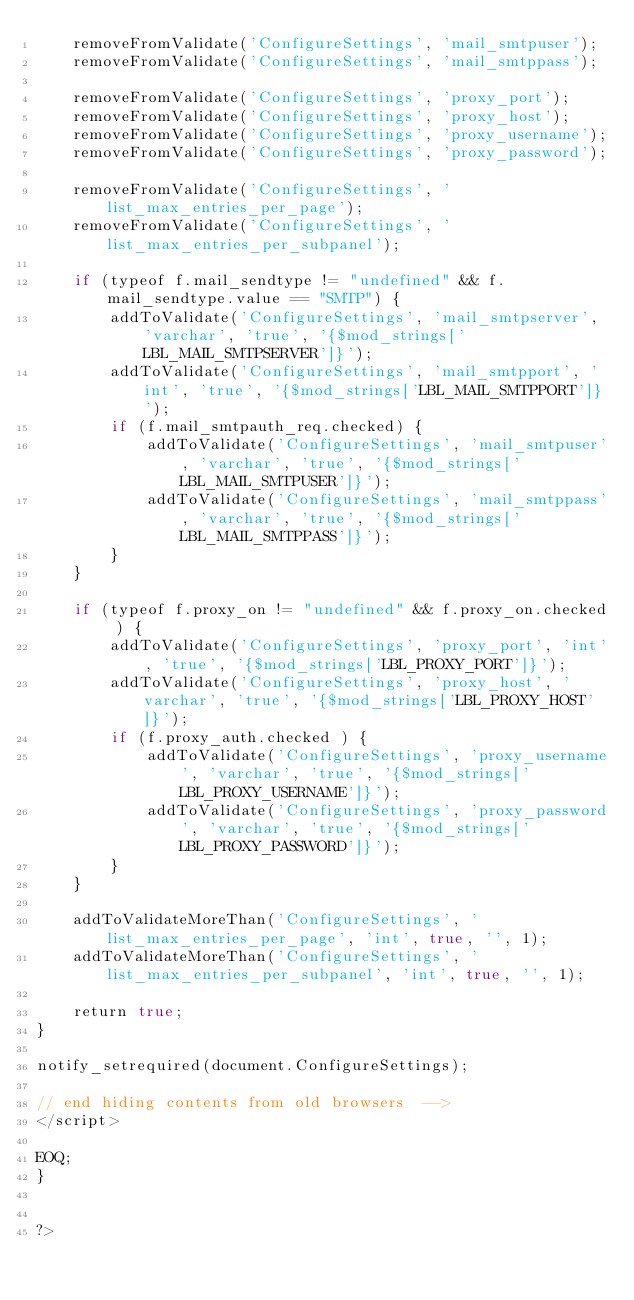<code> <loc_0><loc_0><loc_500><loc_500><_PHP_>	removeFromValidate('ConfigureSettings', 'mail_smtpuser');
	removeFromValidate('ConfigureSettings', 'mail_smtppass');
	
	removeFromValidate('ConfigureSettings', 'proxy_port');
	removeFromValidate('ConfigureSettings', 'proxy_host');
	removeFromValidate('ConfigureSettings', 'proxy_username');
	removeFromValidate('ConfigureSettings', 'proxy_password');
	
	removeFromValidate('ConfigureSettings', 'list_max_entries_per_page');
	removeFromValidate('ConfigureSettings', 'list_max_entries_per_subpanel');	
	
	if (typeof f.mail_sendtype != "undefined" && f.mail_sendtype.value == "SMTP") {
		addToValidate('ConfigureSettings', 'mail_smtpserver', 'varchar', 'true', '{$mod_strings['LBL_MAIL_SMTPSERVER']}');
		addToValidate('ConfigureSettings', 'mail_smtpport', 'int', 'true', '{$mod_strings['LBL_MAIL_SMTPPORT']}');
		if (f.mail_smtpauth_req.checked) {
			addToValidate('ConfigureSettings', 'mail_smtpuser', 'varchar', 'true', '{$mod_strings['LBL_MAIL_SMTPUSER']}');
			addToValidate('ConfigureSettings', 'mail_smtppass', 'varchar', 'true', '{$mod_strings['LBL_MAIL_SMTPPASS']}');
		}
	}
	
	if (typeof f.proxy_on != "undefined" && f.proxy_on.checked ) {
		addToValidate('ConfigureSettings', 'proxy_port', 'int', 'true', '{$mod_strings['LBL_PROXY_PORT']}');
		addToValidate('ConfigureSettings', 'proxy_host', 'varchar', 'true', '{$mod_strings['LBL_PROXY_HOST']}');
		if (f.proxy_auth.checked ) {
			addToValidate('ConfigureSettings', 'proxy_username', 'varchar', 'true', '{$mod_strings['LBL_PROXY_USERNAME']}');
			addToValidate('ConfigureSettings', 'proxy_password', 'varchar', 'true', '{$mod_strings['LBL_PROXY_PASSWORD']}');
		}
	}
	
	addToValidateMoreThan('ConfigureSettings', 'list_max_entries_per_page', 'int', true, '', 1);
	addToValidateMoreThan('ConfigureSettings', 'list_max_entries_per_subpanel', 'int', true, '', 1);
	
	return true;
}

notify_setrequired(document.ConfigureSettings);

// end hiding contents from old browsers  -->
</script>

EOQ;
}


?>
</code> 